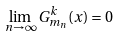<formula> <loc_0><loc_0><loc_500><loc_500>\lim _ { n \to \infty } G ^ { k } _ { m _ { n } } ( x ) = 0</formula> 